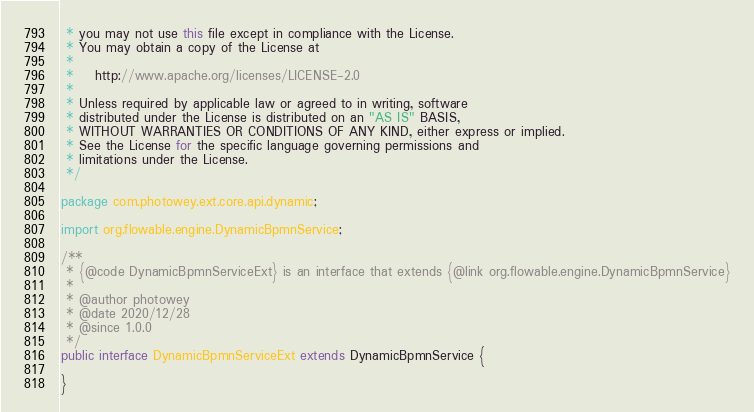Convert code to text. <code><loc_0><loc_0><loc_500><loc_500><_Java_> * you may not use this file except in compliance with the License.
 * You may obtain a copy of the License at
 *
 *    http://www.apache.org/licenses/LICENSE-2.0
 *
 * Unless required by applicable law or agreed to in writing, software
 * distributed under the License is distributed on an "AS IS" BASIS,
 * WITHOUT WARRANTIES OR CONDITIONS OF ANY KIND, either express or implied.
 * See the License for the specific language governing permissions and
 * limitations under the License.
 */

package com.photowey.ext.core.api.dynamic;

import org.flowable.engine.DynamicBpmnService;

/**
 * {@code DynamicBpmnServiceExt} is an interface that extends {@link org.flowable.engine.DynamicBpmnService}
 *
 * @author photowey
 * @date 2020/12/28
 * @since 1.0.0
 */
public interface DynamicBpmnServiceExt extends DynamicBpmnService {

}
</code> 